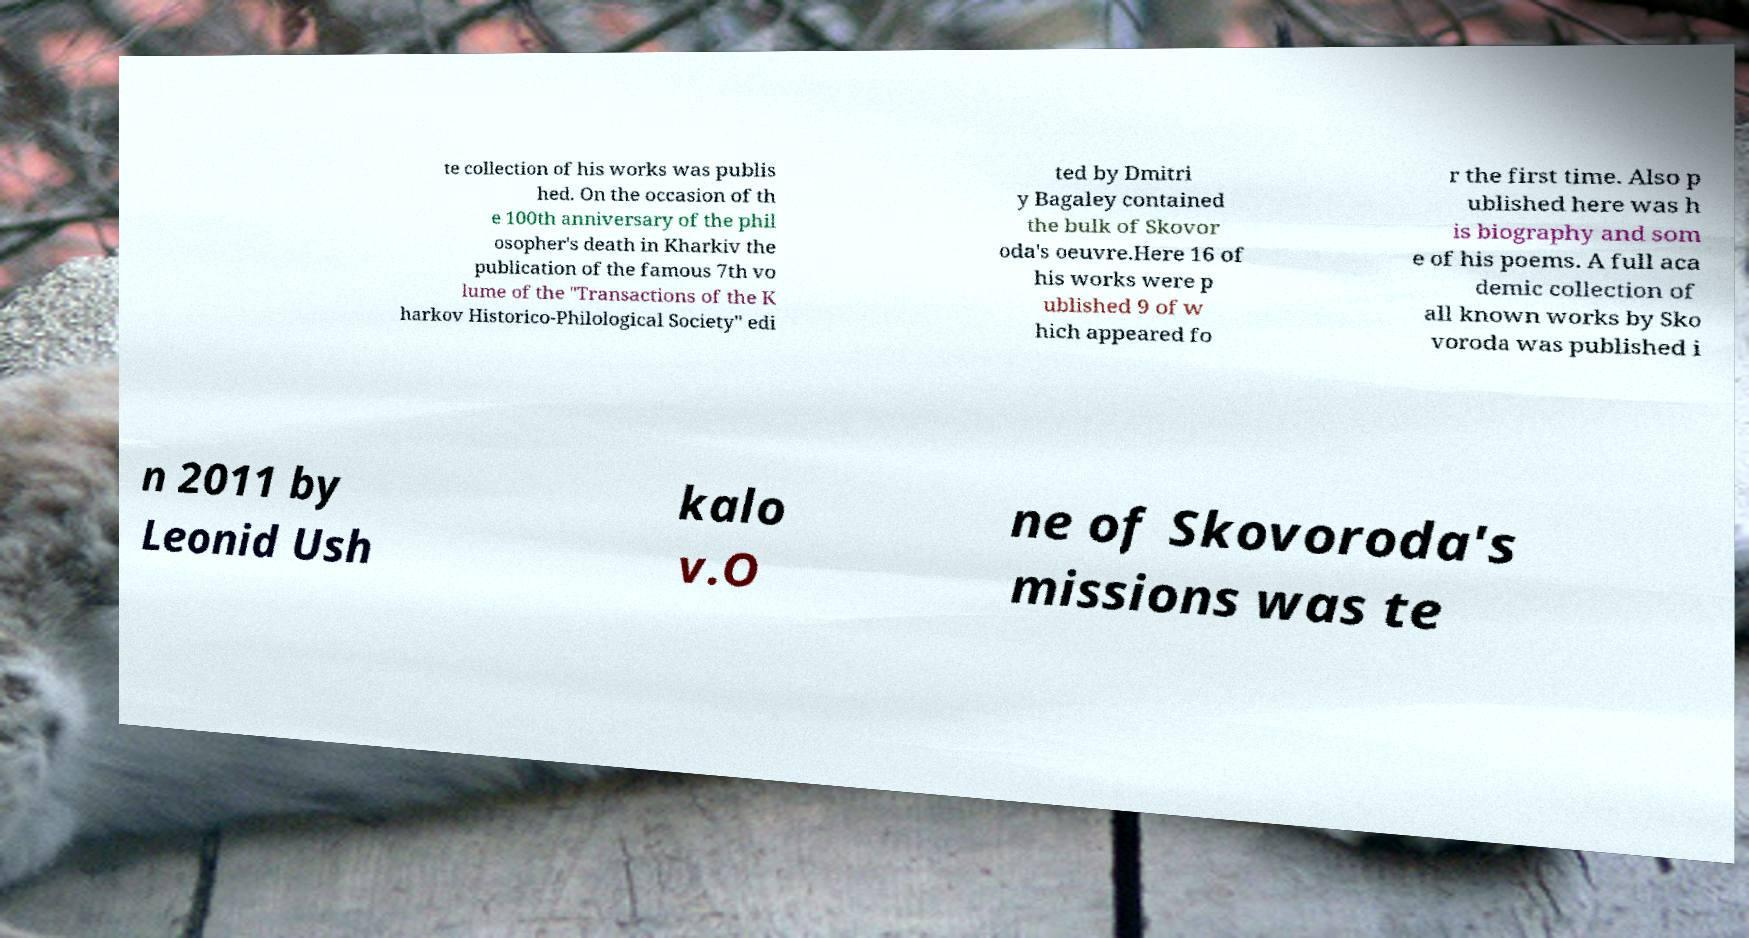What messages or text are displayed in this image? I need them in a readable, typed format. te collection of his works was publis hed. On the occasion of th e 100th anniversary of the phil osopher's death in Kharkiv the publication of the famous 7th vo lume of the "Transactions of the K harkov Historico-Philological Society" edi ted by Dmitri y Bagaley contained the bulk of Skovor oda's oeuvre.Here 16 of his works were p ublished 9 of w hich appeared fo r the first time. Also p ublished here was h is biography and som e of his poems. A full aca demic collection of all known works by Sko voroda was published i n 2011 by Leonid Ush kalo v.O ne of Skovoroda's missions was te 